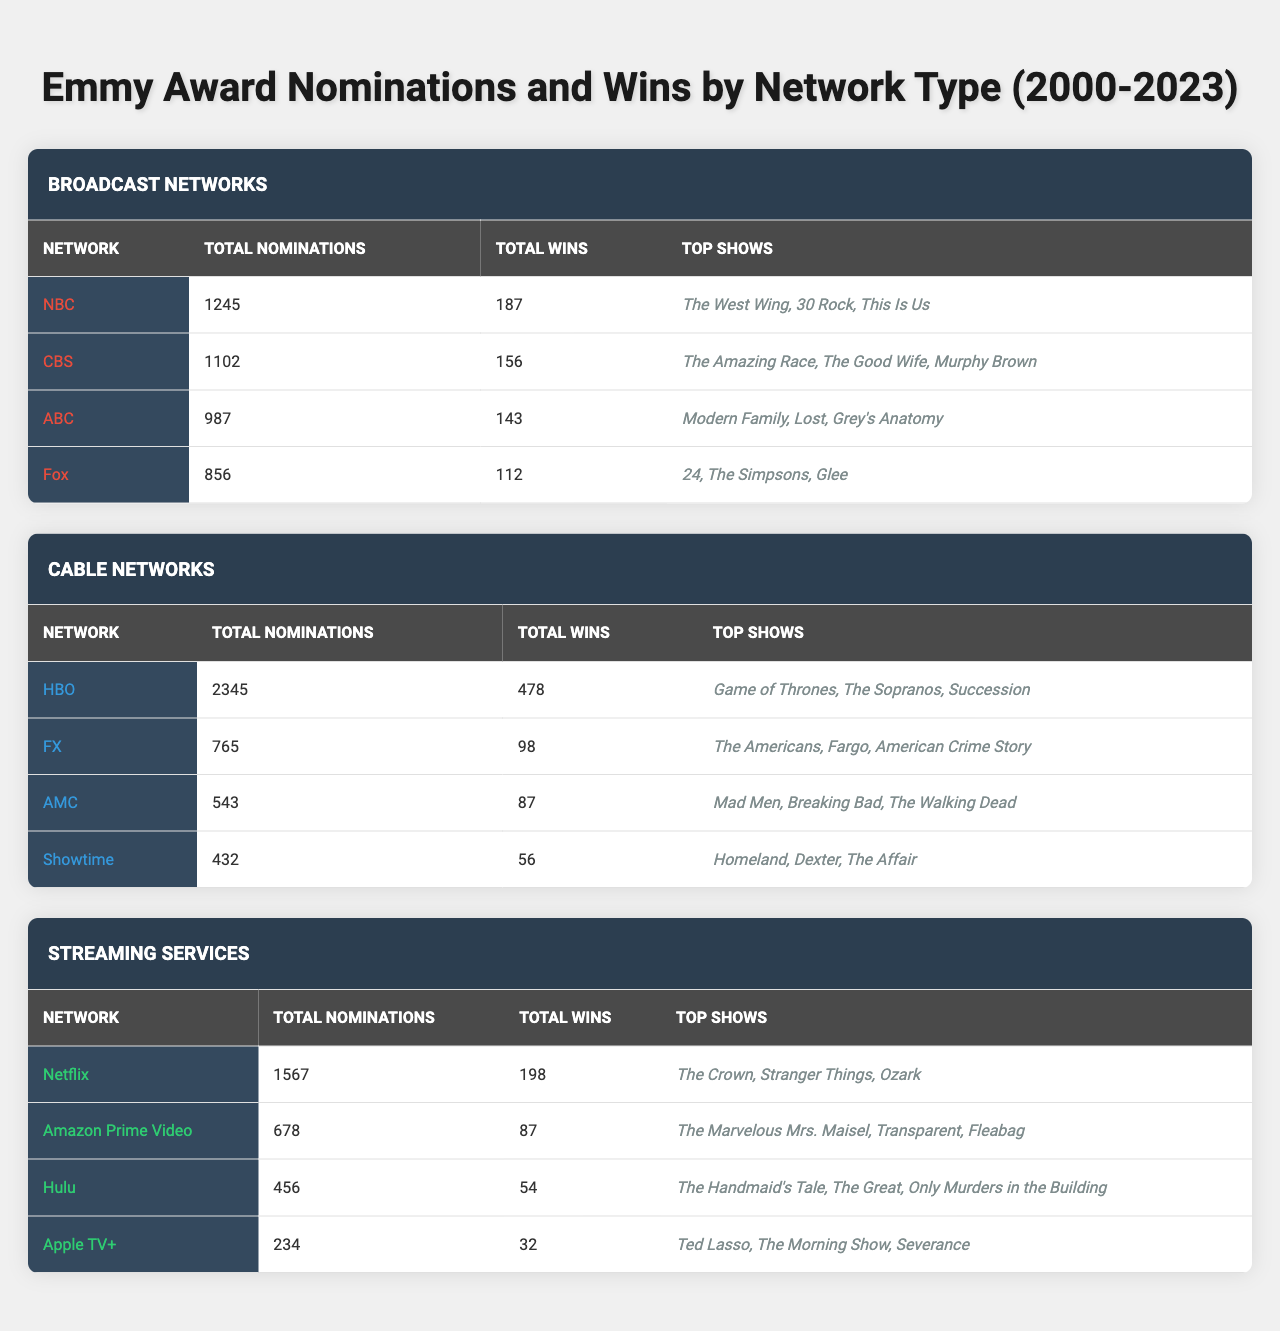What is the total number of nominations for HBO? The table shows that HBO has a total of 2345 nominations listed under Cable Networks.
Answer: 2345 Which broadcast network has the highest number of total wins? By comparing the Total Wins in the Broadcast Networks section, NBC with 187 wins has more than CBS (156), ABC (143), and Fox (112), making it the highest.
Answer: NBC What is the combined total of nominations for all broadcast networks? Adding the nominations for each broadcast network gives: 1245 (NBC) + 1102 (CBS) + 987 (ABC) + 856 (Fox) = 4190.
Answer: 4190 Does Amazon Prime Video have more total wins than Hulu? Looking at the data, Amazon Prime Video has 87 wins and Hulu has 54 wins, so Amazon Prime Video indeed has more wins.
Answer: Yes Identify the network with the least number of total nominations. Comparing the Total Nominations, Apple TV+ has the least with 234 nominations compared to all other networks.
Answer: Apple TV+ What is the difference in total wins between Showtime and FX? Showtime has 56 wins and FX has 98 wins. The difference is calculated as 98 (FX) - 56 (Showtime) = 42.
Answer: 42 Which type of network (broadcast, cable, or streaming) has the highest total nominations? The total nominations can be summed up for each type: Broadcast (4190) + Cable (4324) + Streaming (2435). Cable has the highest count at 4324.
Answer: Cable How many total wins do cable networks have compared to streaming networks? Cable networks' total wins = 478 (HBO) + 98 (FX) + 87 (AMC) + 56 (Showtime) = 719; Streaming networks' total wins = 198 (Netflix) + 87 (Amazon Prime) + 54 (Hulu) + 32 (Apple TV+) = 371. Cable networks win by 348.
Answer: 348 Which network had the top show "The Crown"? The show "The Crown" is listed under Netflix, indicating that Netflix had it as a top show.
Answer: Netflix Is it true that AMC has more total nominations than Showtime? Checking the values, AMC has 543 nominations while Showtime has 432 nominations, thus AMC indeed has more nominations.
Answer: Yes 